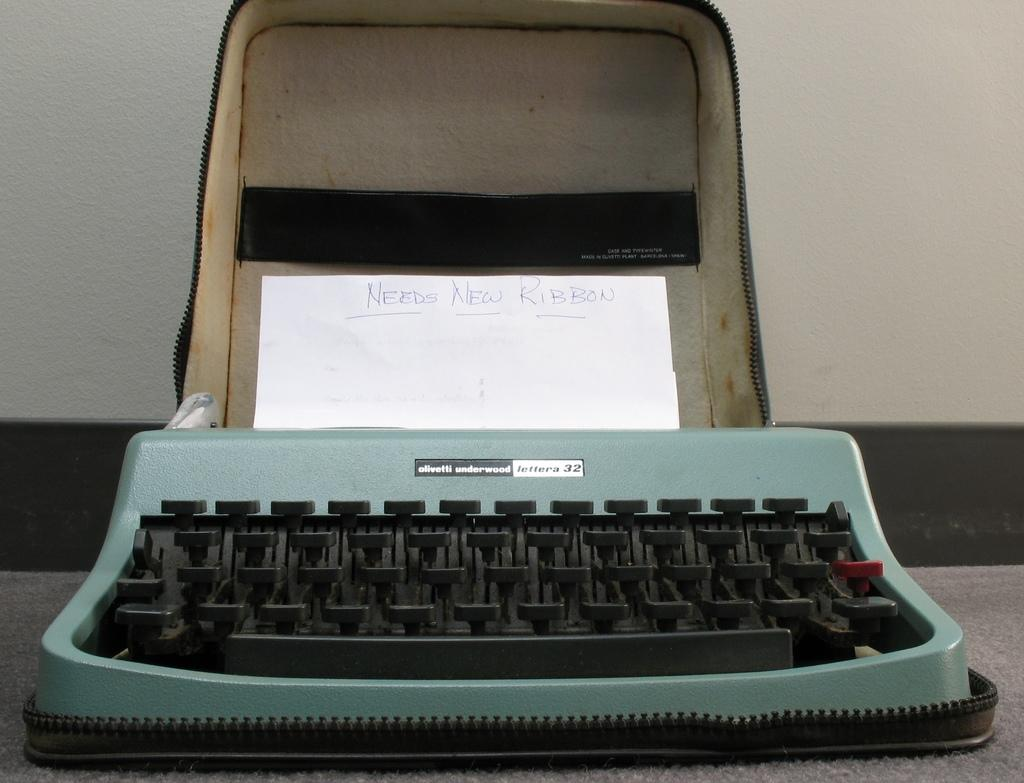<image>
Offer a succinct explanation of the picture presented. An olivetti underwood lettera 32 typewriter containing a piece of paper that says Needs New Ribbon. 